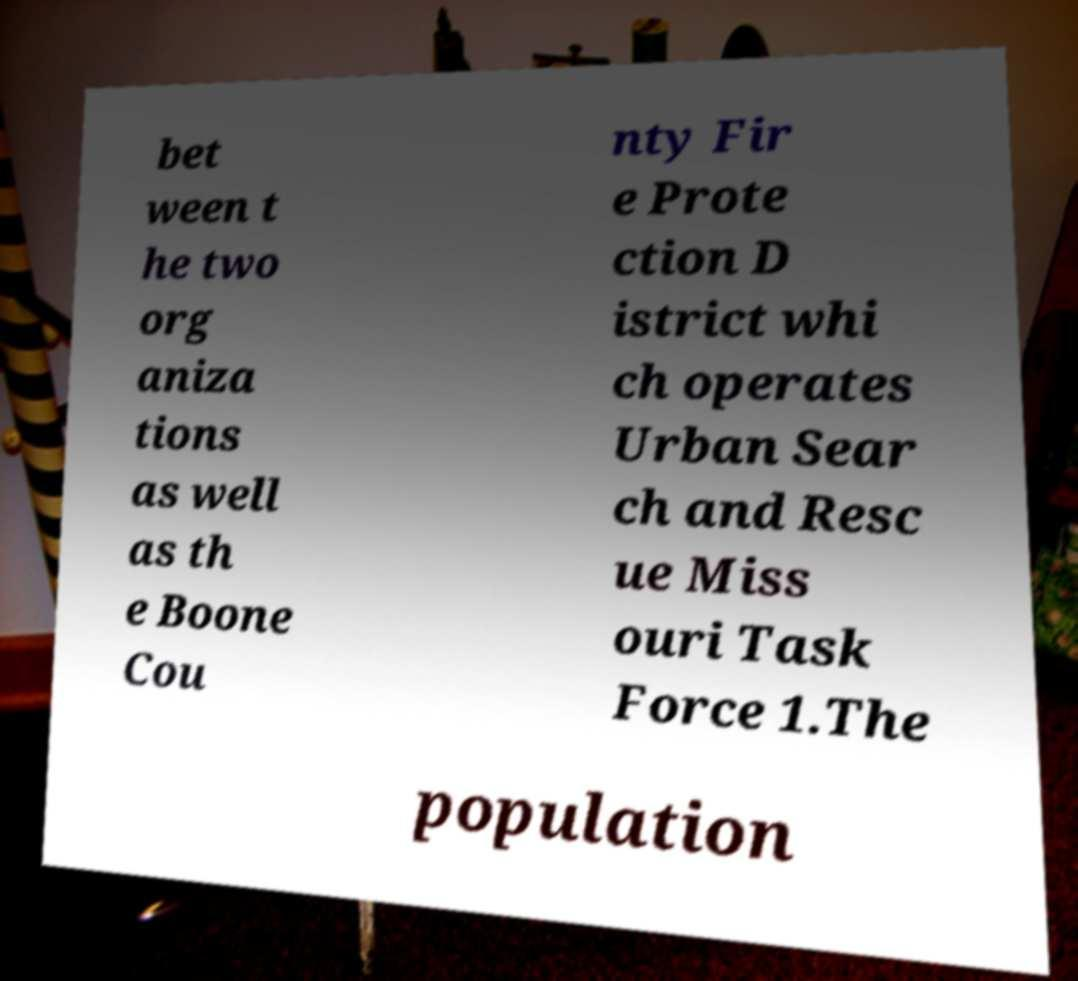Could you assist in decoding the text presented in this image and type it out clearly? bet ween t he two org aniza tions as well as th e Boone Cou nty Fir e Prote ction D istrict whi ch operates Urban Sear ch and Resc ue Miss ouri Task Force 1.The population 